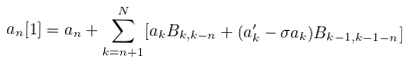<formula> <loc_0><loc_0><loc_500><loc_500>a _ { n } [ 1 ] = a _ { n } + \sum _ { k = n + 1 } ^ { N } [ a _ { k } B _ { k , k - n } + ( a _ { k } ^ { \prime } - \sigma a _ { k } ) B _ { k - 1 , k - 1 - n } ]</formula> 